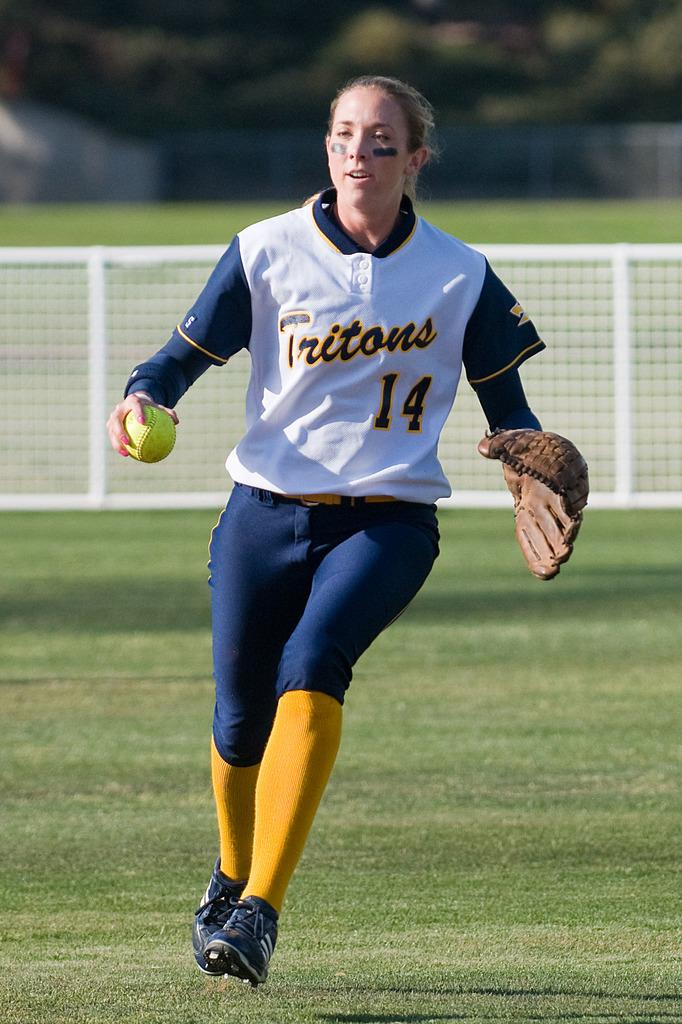<image>
Describe the image concisely. a woman in a Tritons 14 jersey running on a sports field 